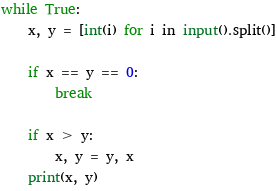Convert code to text. <code><loc_0><loc_0><loc_500><loc_500><_Python_>while True:
    x, y = [int(i) for i in input().split()]

    if x == y == 0:
        break

    if x > y:
        x, y = y, x
    print(x, y)</code> 